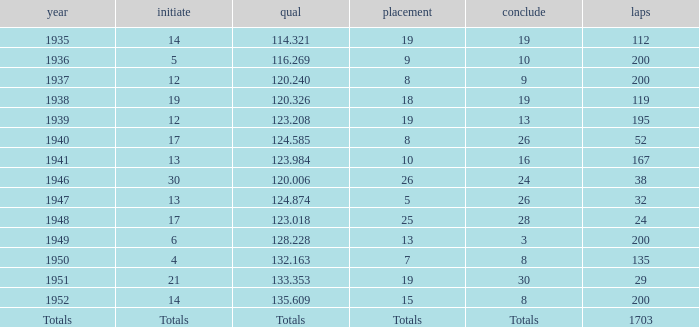In 1937, what was the finish? 9.0. 